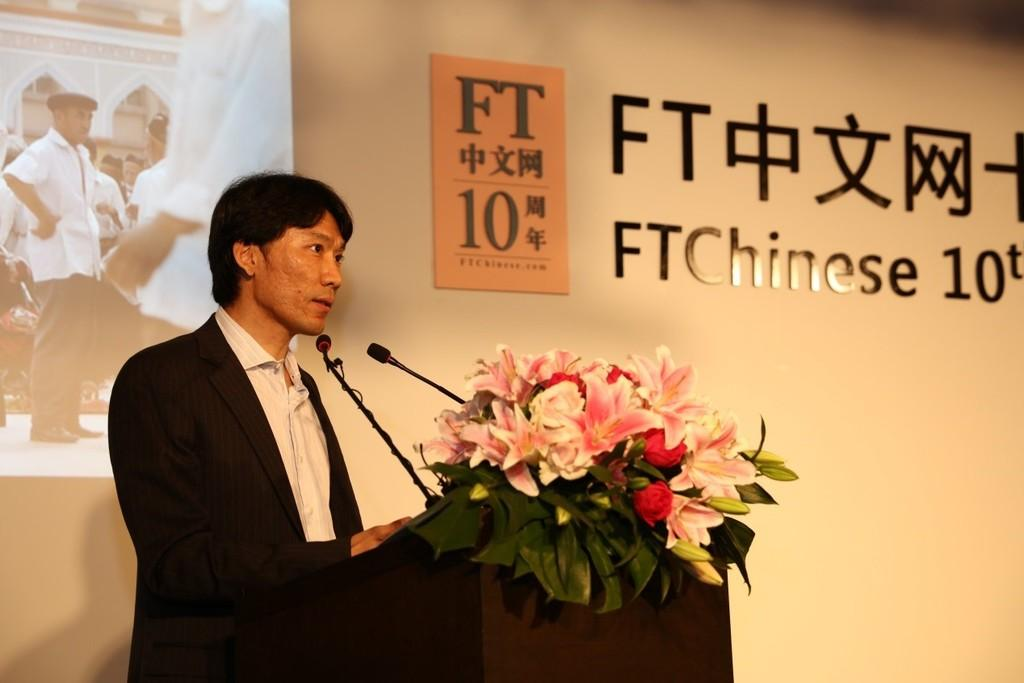Who is the person in the image? There is a man in the image. What is in front of the man? There are microphones and flowers in front of the man. What can be seen in the background of the image? There is a projector screen, a poster, and text on the wall in the background of the image. What type of wood is the man using to hold his stomach in the image? There is no wood or any indication of the man holding his stomach in the image. 